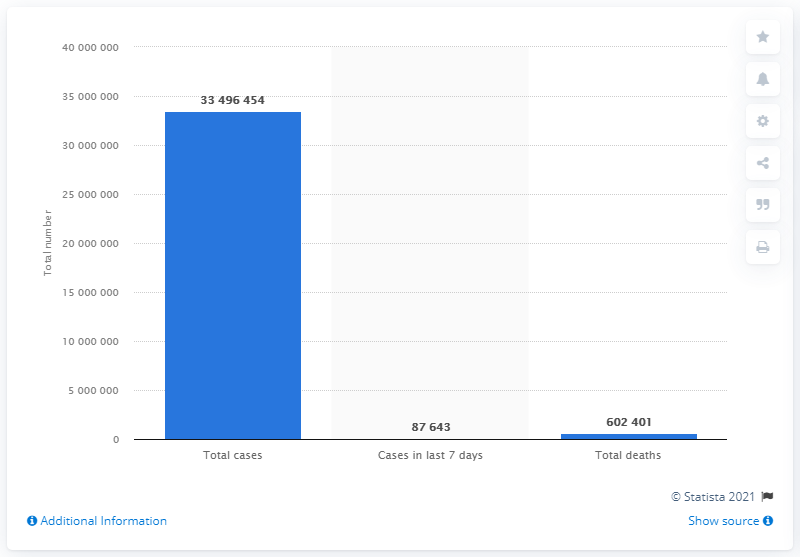List a handful of essential elements in this visual. The COVID-19 pandemic has resulted in an alarming number of deaths, with at least 6,024,010 cases reported as of February 14, 2023. During the COVID-19 pandemic, there were approximately 602,401 deaths reported among cases of the disease. 